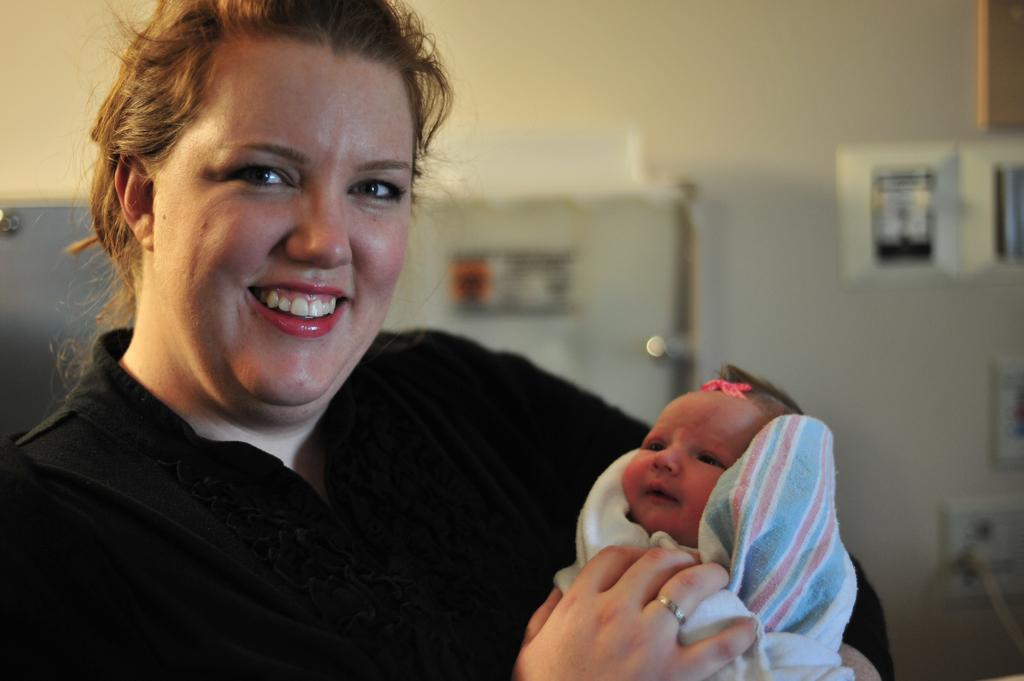Who is the main subject in the image? There is a woman in the image. What is the woman doing in the image? The woman is carrying a baby in her hands. Can you describe the background of the image? The background of the image is blurry. Are there any objects visible in the background? Yes, there are a few objects visible in the background. What type of pets can be seen in the image? There are no pets visible in the image. What religious symbols are present in the image? There is no indication of any religious symbols in the image. 